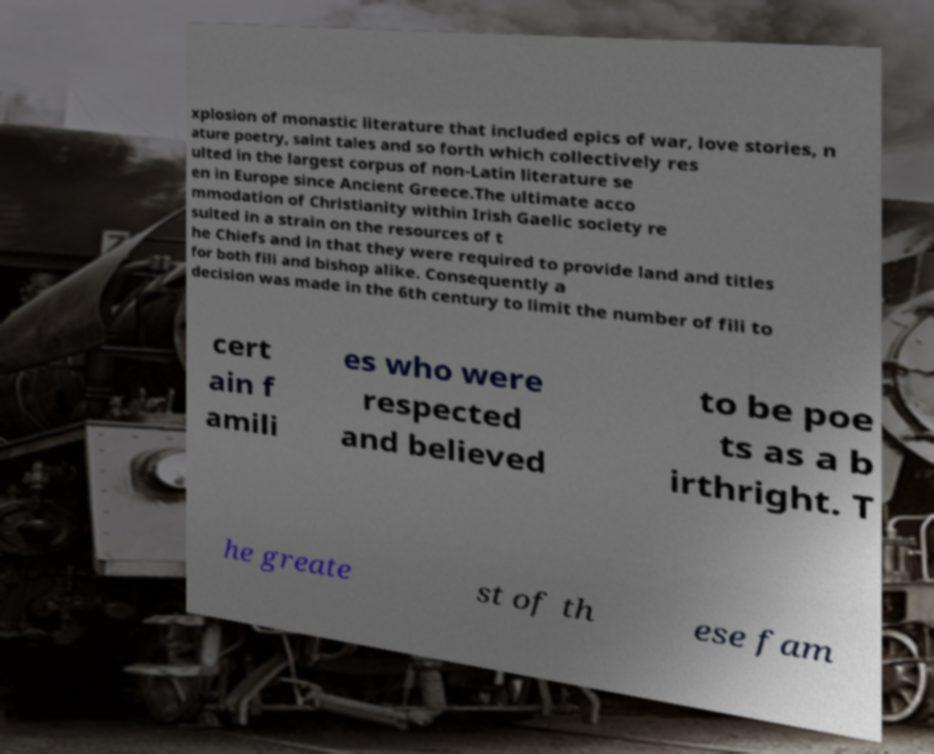For documentation purposes, I need the text within this image transcribed. Could you provide that? xplosion of monastic literature that included epics of war, love stories, n ature poetry, saint tales and so forth which collectively res ulted in the largest corpus of non-Latin literature se en in Europe since Ancient Greece.The ultimate acco mmodation of Christianity within Irish Gaelic society re sulted in a strain on the resources of t he Chiefs and in that they were required to provide land and titles for both fili and bishop alike. Consequently a decision was made in the 6th century to limit the number of fili to cert ain f amili es who were respected and believed to be poe ts as a b irthright. T he greate st of th ese fam 